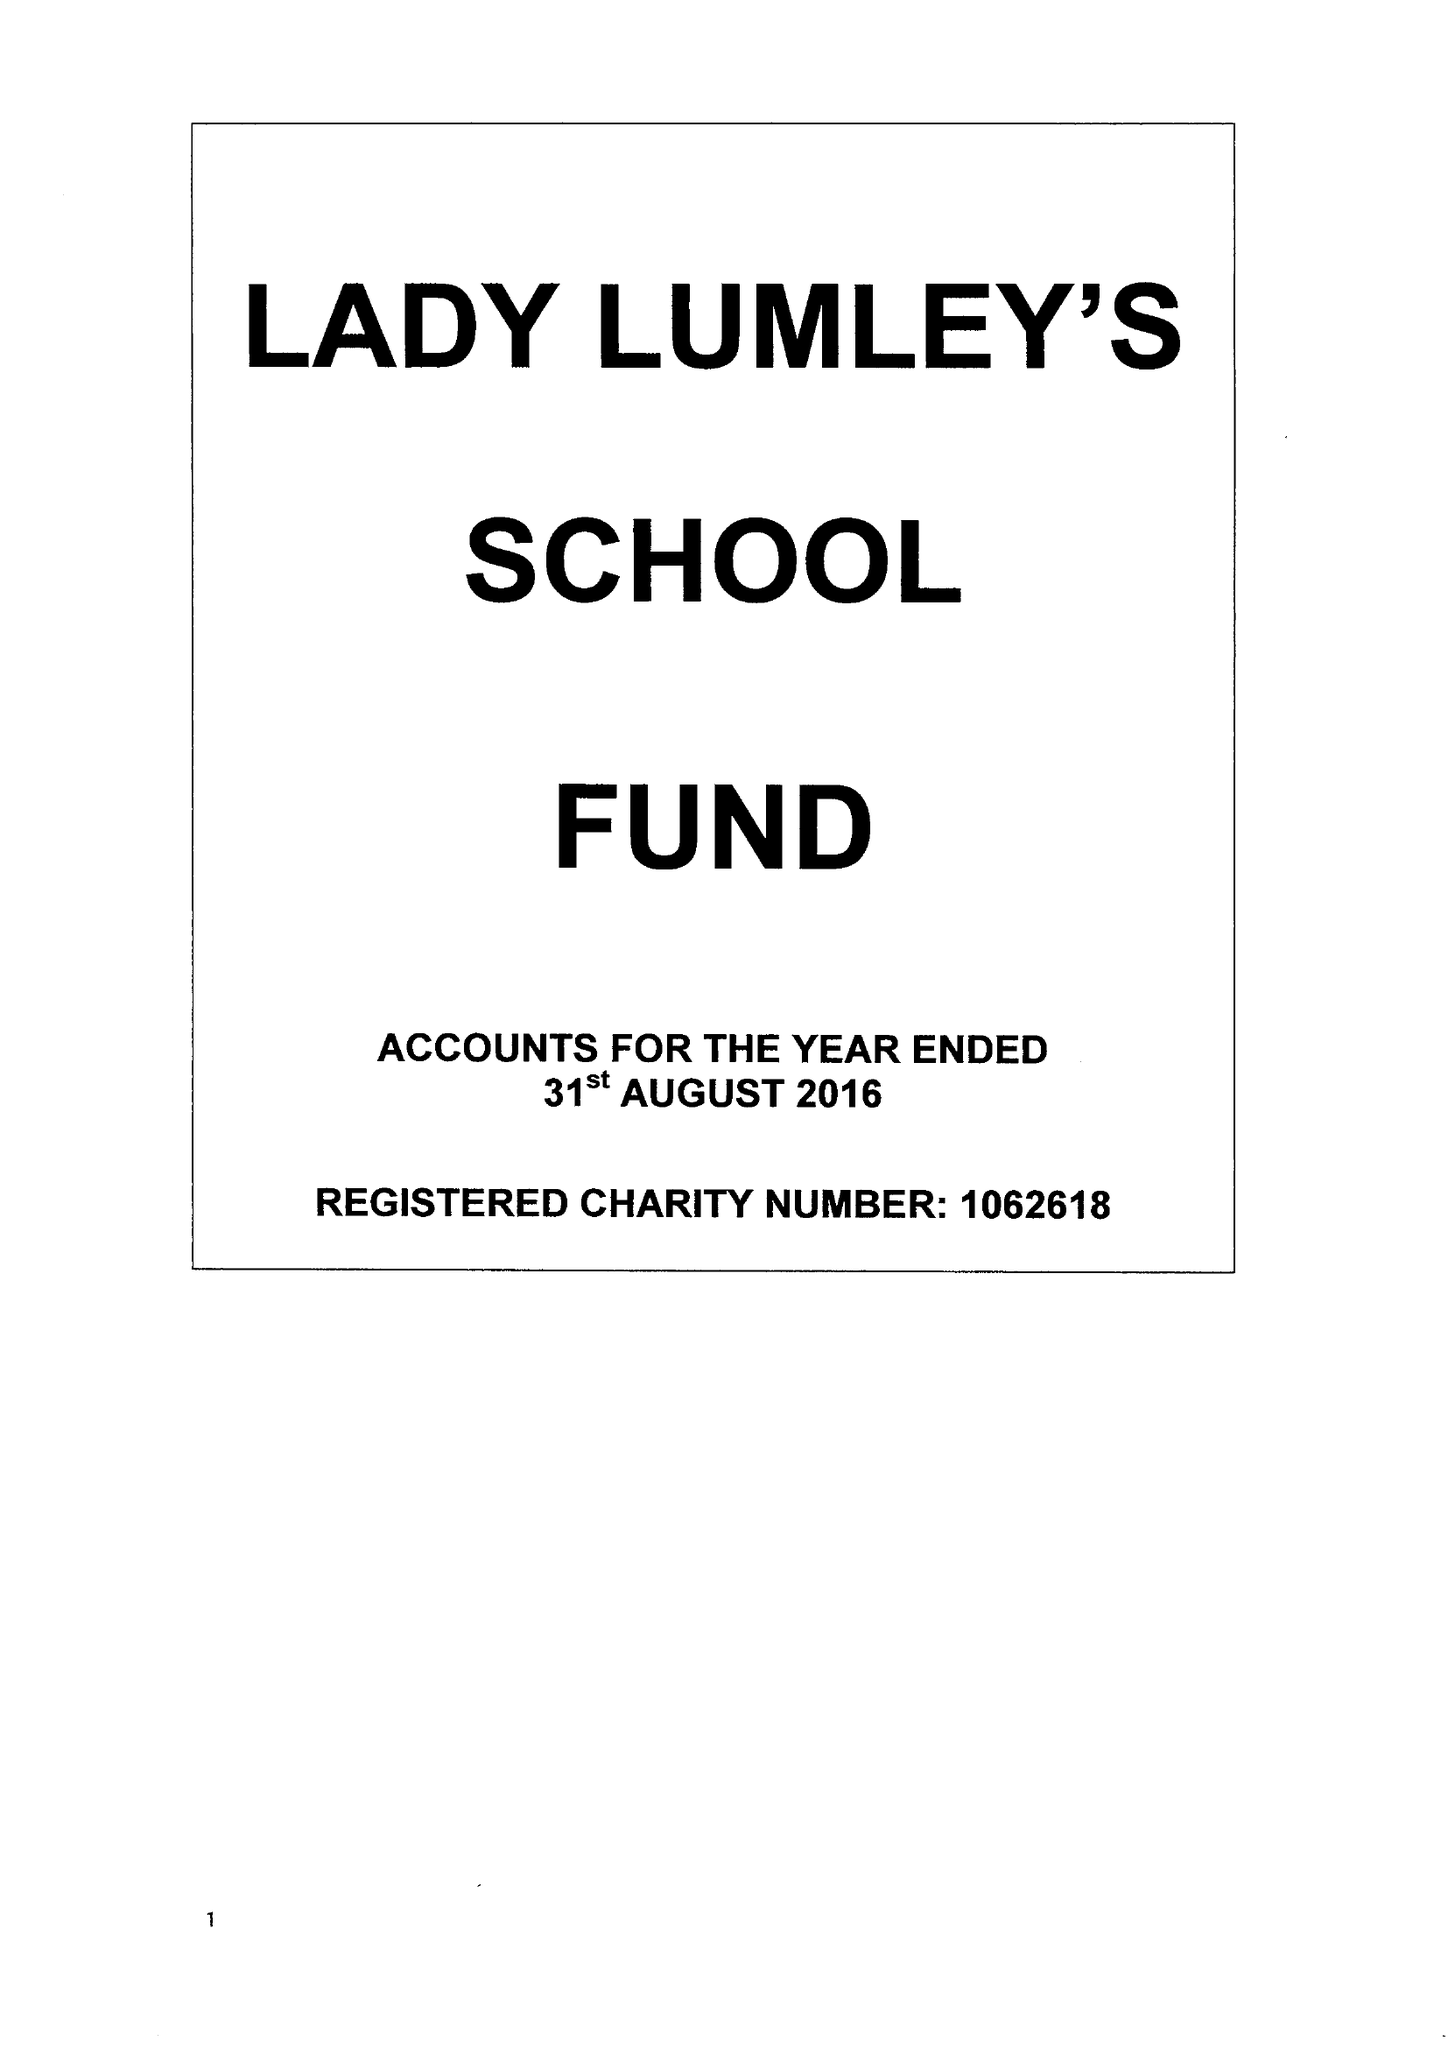What is the value for the report_date?
Answer the question using a single word or phrase. 2016-08-31 